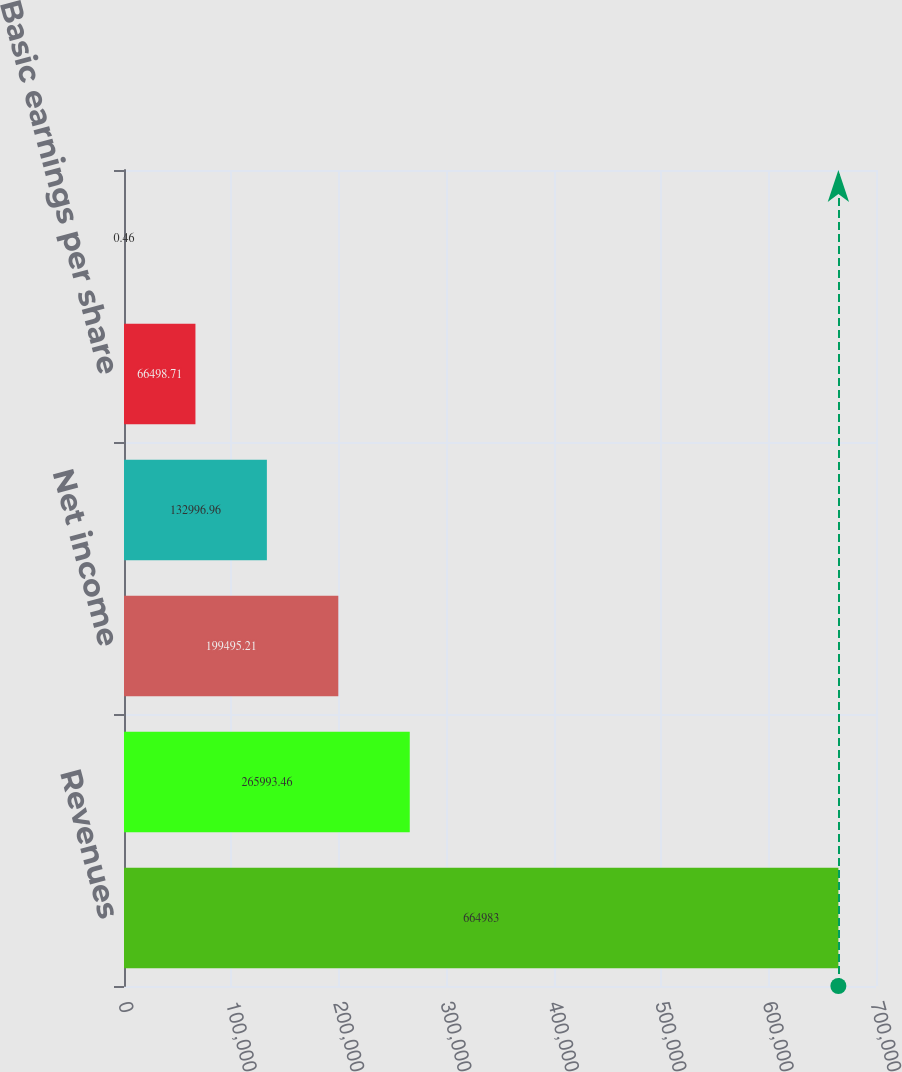Convert chart to OTSL. <chart><loc_0><loc_0><loc_500><loc_500><bar_chart><fcel>Revenues<fcel>Operating income<fcel>Net income<fcel>Net income attributable to<fcel>Basic earnings per share<fcel>Diluted earnings per share<nl><fcel>664983<fcel>265993<fcel>199495<fcel>132997<fcel>66498.7<fcel>0.46<nl></chart> 